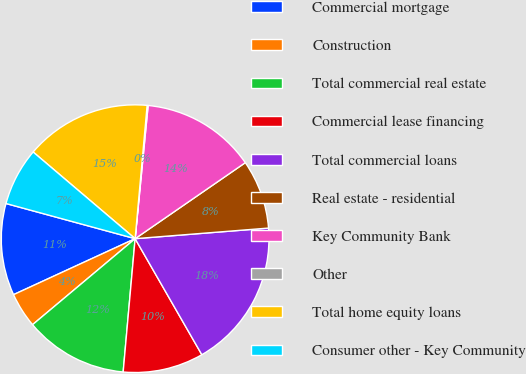Convert chart to OTSL. <chart><loc_0><loc_0><loc_500><loc_500><pie_chart><fcel>Commercial mortgage<fcel>Construction<fcel>Total commercial real estate<fcel>Commercial lease financing<fcel>Total commercial loans<fcel>Real estate - residential<fcel>Key Community Bank<fcel>Other<fcel>Total home equity loans<fcel>Consumer other - Key Community<nl><fcel>11.1%<fcel>4.24%<fcel>12.47%<fcel>9.73%<fcel>17.96%<fcel>8.35%<fcel>13.84%<fcel>0.12%<fcel>15.22%<fcel>6.98%<nl></chart> 